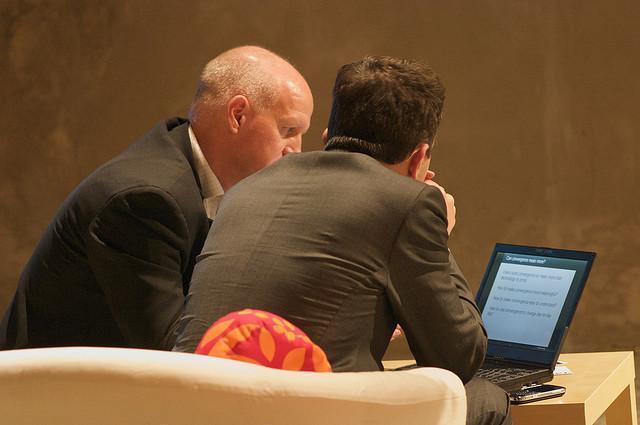What type of battery is best for laptop?
Select the correct answer and articulate reasoning with the following format: 'Answer: answer
Rationale: rationale.'
Options: Nimh, peds, lithium-ion, nicad. Answer: nimh.
Rationale: The best battery is one that is for nimh. 